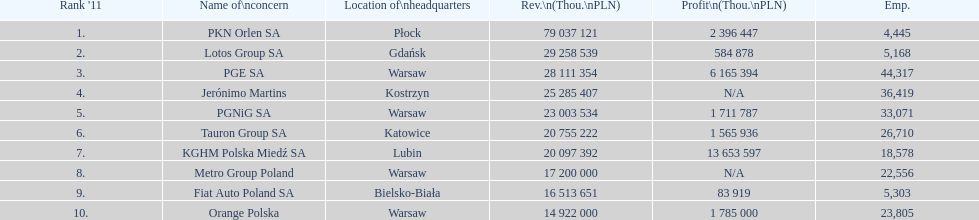What is the number of employees who work for pgnig sa? 33,071. Can you give me this table as a dict? {'header': ["Rank '11", 'Name of\\nconcern', 'Location of\\nheadquarters', 'Rev.\\n(Thou.\\nPLN)', 'Profit\\n(Thou.\\nPLN)', 'Emp.'], 'rows': [['1.', 'PKN Orlen SA', 'Płock', '79 037 121', '2 396 447', '4,445'], ['2.', 'Lotos Group SA', 'Gdańsk', '29 258 539', '584 878', '5,168'], ['3.', 'PGE SA', 'Warsaw', '28 111 354', '6 165 394', '44,317'], ['4.', 'Jerónimo Martins', 'Kostrzyn', '25 285 407', 'N/A', '36,419'], ['5.', 'PGNiG SA', 'Warsaw', '23 003 534', '1 711 787', '33,071'], ['6.', 'Tauron Group SA', 'Katowice', '20 755 222', '1 565 936', '26,710'], ['7.', 'KGHM Polska Miedź SA', 'Lubin', '20 097 392', '13 653 597', '18,578'], ['8.', 'Metro Group Poland', 'Warsaw', '17 200 000', 'N/A', '22,556'], ['9.', 'Fiat Auto Poland SA', 'Bielsko-Biała', '16 513 651', '83 919', '5,303'], ['10.', 'Orange Polska', 'Warsaw', '14 922 000', '1 785 000', '23,805']]} 